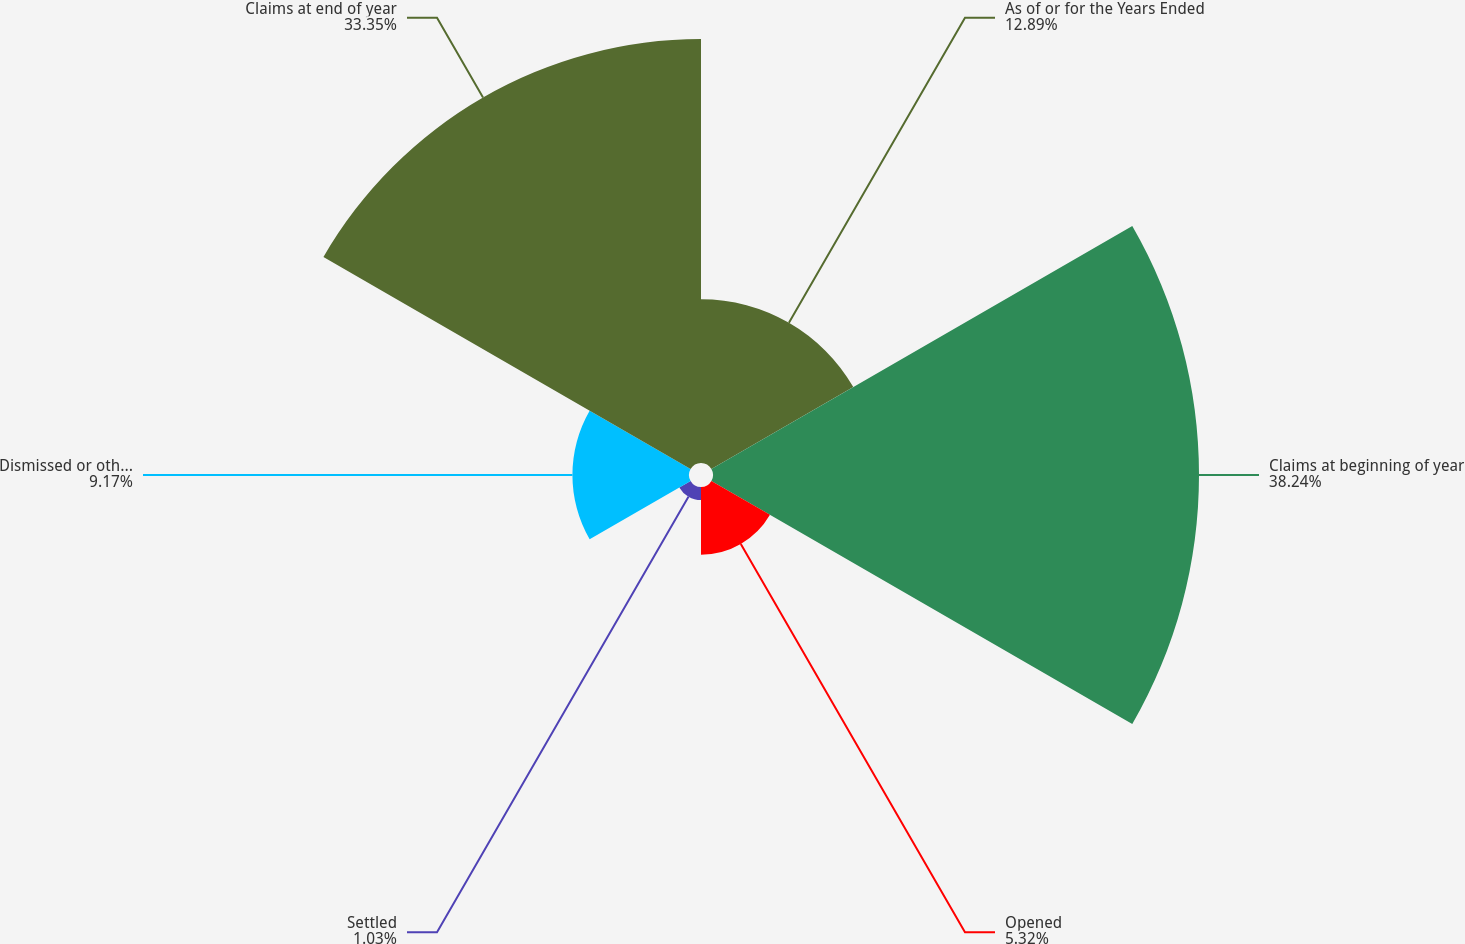Convert chart to OTSL. <chart><loc_0><loc_0><loc_500><loc_500><pie_chart><fcel>As of or for the Years Ended<fcel>Claims at beginning of year<fcel>Opened<fcel>Settled<fcel>Dismissed or otherwise<fcel>Claims at end of year<nl><fcel>12.89%<fcel>38.23%<fcel>5.32%<fcel>1.03%<fcel>9.17%<fcel>33.35%<nl></chart> 